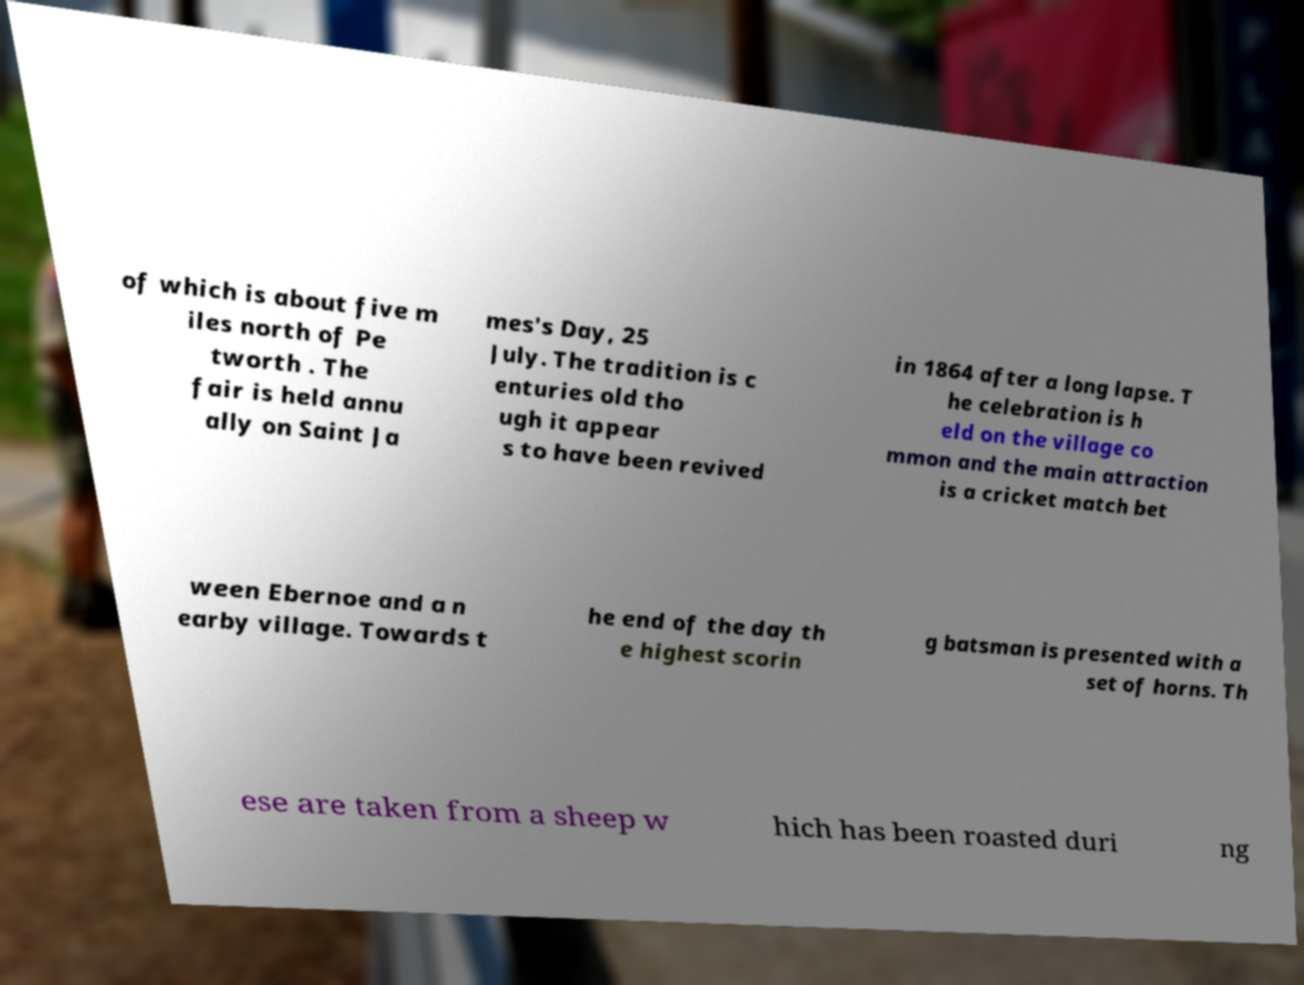Can you read and provide the text displayed in the image?This photo seems to have some interesting text. Can you extract and type it out for me? of which is about five m iles north of Pe tworth . The fair is held annu ally on Saint Ja mes's Day, 25 July. The tradition is c enturies old tho ugh it appear s to have been revived in 1864 after a long lapse. T he celebration is h eld on the village co mmon and the main attraction is a cricket match bet ween Ebernoe and a n earby village. Towards t he end of the day th e highest scorin g batsman is presented with a set of horns. Th ese are taken from a sheep w hich has been roasted duri ng 